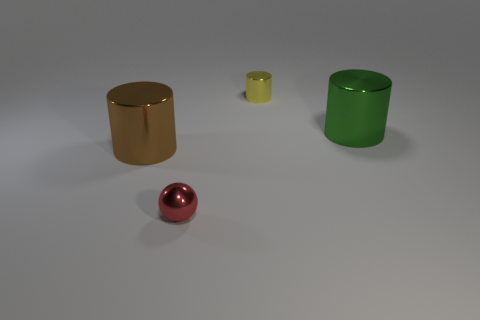Is there any other thing that has the same shape as the red metal thing?
Offer a very short reply. No. Are any red metallic cylinders visible?
Your response must be concise. No. Is the number of small shiny balls less than the number of blue rubber cylinders?
Offer a very short reply. No. How many green cylinders have the same material as the red ball?
Offer a terse response. 1. There is another tiny object that is made of the same material as the red object; what color is it?
Offer a terse response. Yellow. What is the shape of the green thing?
Ensure brevity in your answer.  Cylinder. How many tiny cylinders are the same color as the tiny metallic sphere?
Offer a very short reply. 0. What shape is the yellow thing that is the same size as the red metal sphere?
Make the answer very short. Cylinder. Is there a shiny cylinder of the same size as the green object?
Your answer should be compact. Yes. There is another thing that is the same size as the green metallic thing; what is its material?
Your response must be concise. Metal. 